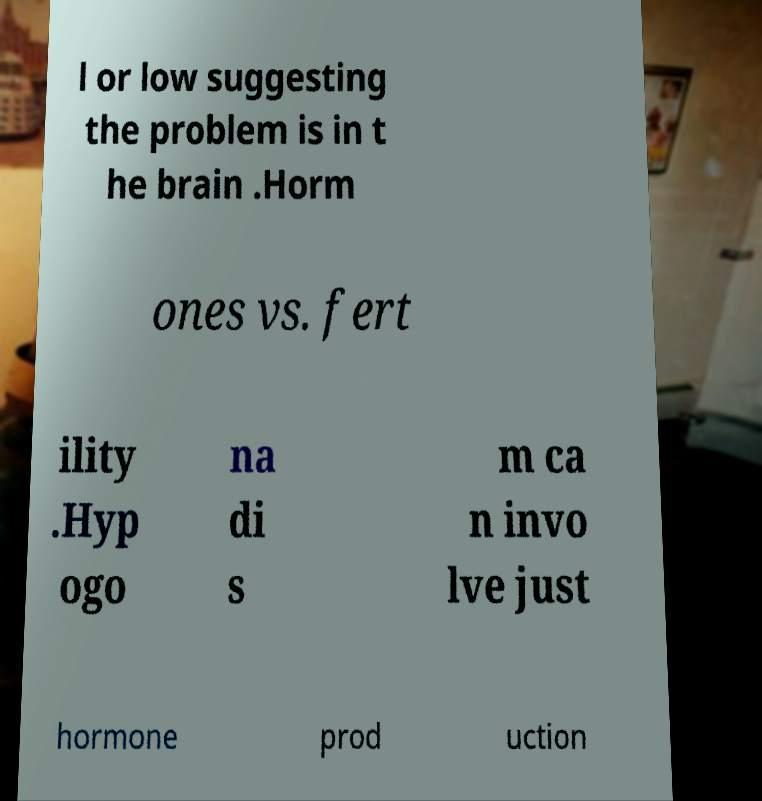Could you extract and type out the text from this image? l or low suggesting the problem is in t he brain .Horm ones vs. fert ility .Hyp ogo na di s m ca n invo lve just hormone prod uction 